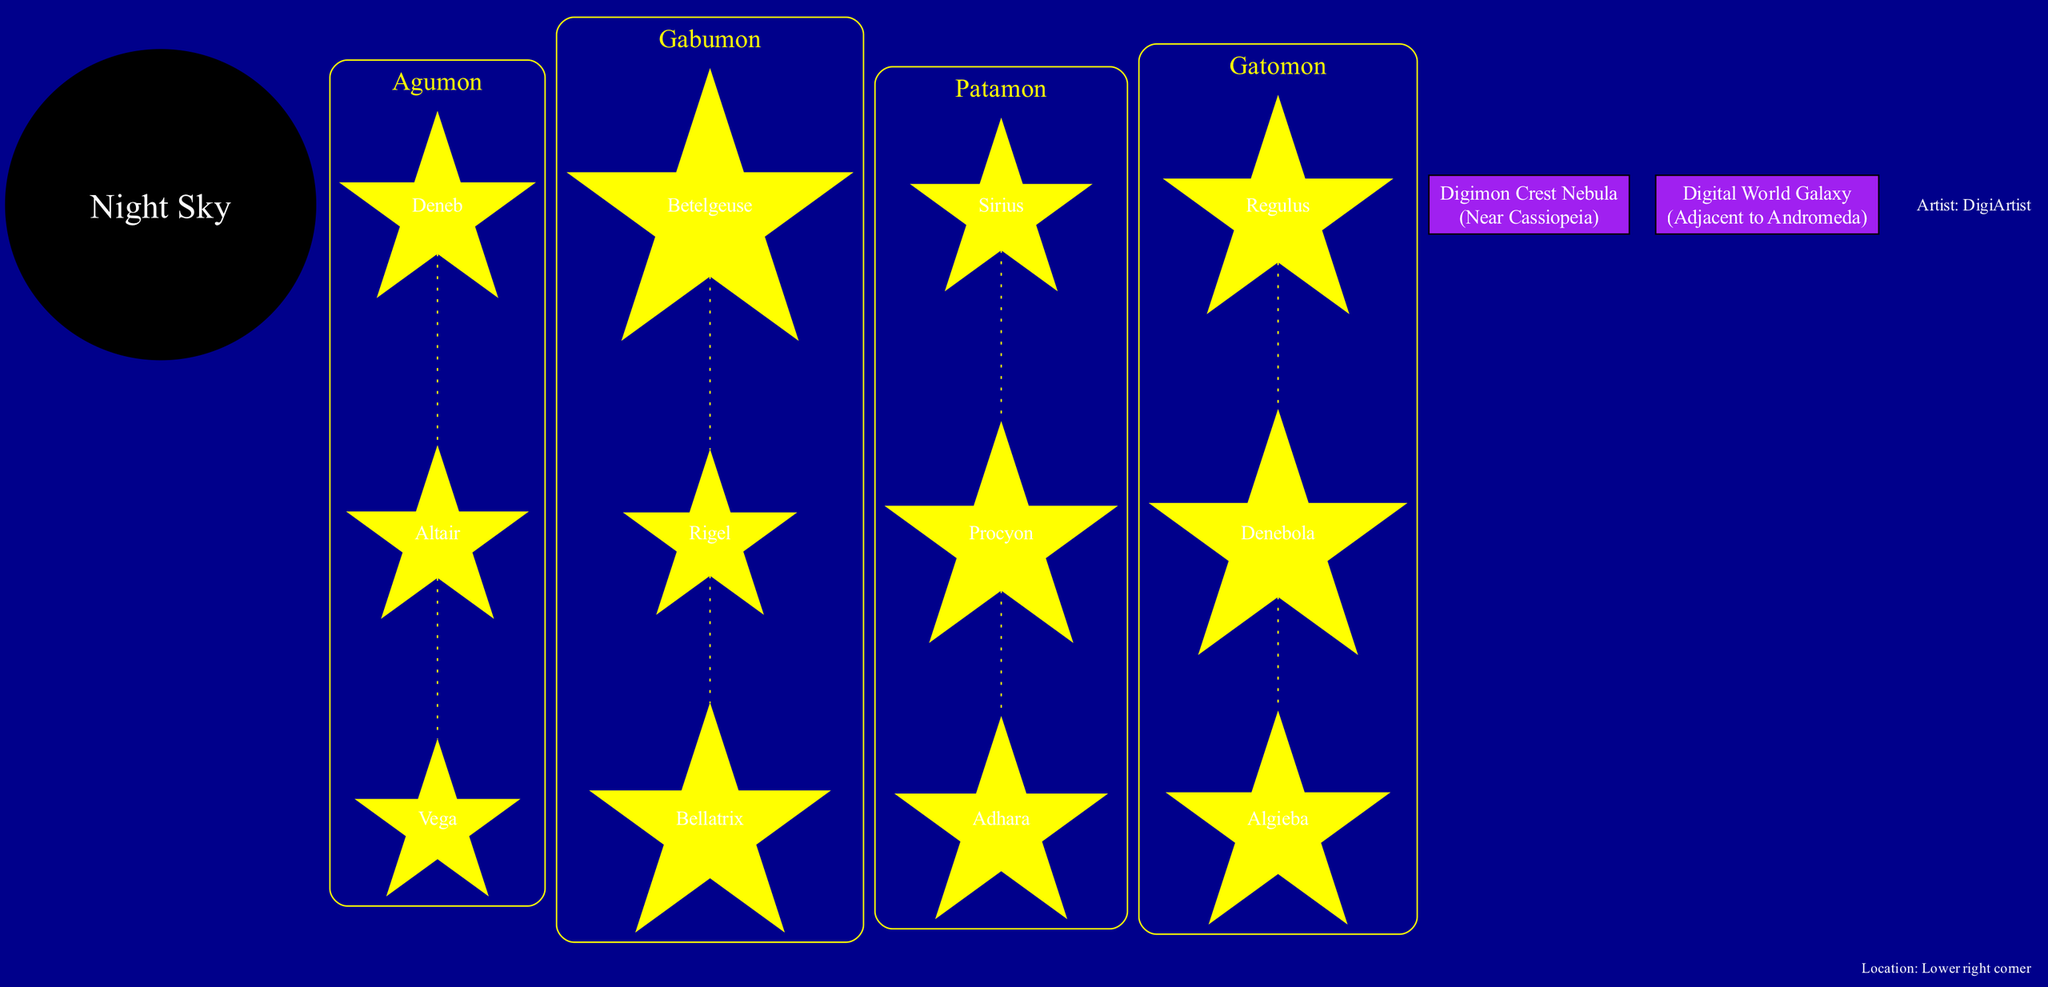What are the names of the constellations in the diagram? The constellations listed in the diagram are Agumon, Gabumon, Patamon, and Gatomon. These names are directly mentioned under the respective constellation labels.
Answer: Agumon, Gabumon, Patamon, Gatomon How many stars are included in the Agumon constellation? The Agumon constellation has three stars: Deneb, Altair, and Vega. This can be counted by looking at the star nodes listed under the Agumon label.
Answer: 3 What shape is associated with the Gabumon constellation? The Gabumon constellation is associated with a wolf-like shape, as described within the constellation details in the diagram.
Answer: Wolf-like Which notable feature is located near Cassiopeia? The Digimon Crest Nebula is located near Cassiopeia, as indicated in the notable features section of the diagram.
Answer: Digimon Crest Nebula What color are the stars representing the constellations? The stars in the constellations are yellow, which is specified in the node attributes added for each star in the diagram.
Answer: Yellow How many notable features are depicted in the diagram? There are two notable features mentioned: the Digimon Crest Nebula and the Digital World Galaxy. By counting these, we find they are listed in the notable features section.
Answer: 2 What is the shape of the Patamon constellation? The Patamon constellation is described as a flying mammal shape, which is noted clearly along with the constellation's name in the diagram.
Answer: Flying mammal What color is used for the background of the diagram? The background color of the diagram is dark blue, as specified in the graph attributes at the start of the code that generates the diagram.
Answer: Dark blue Where is the artist's signature located in the diagram? The artist's signature is located in the lower right corner, which is indicated in the artist signature section within the diagram.
Answer: Lower right corner 